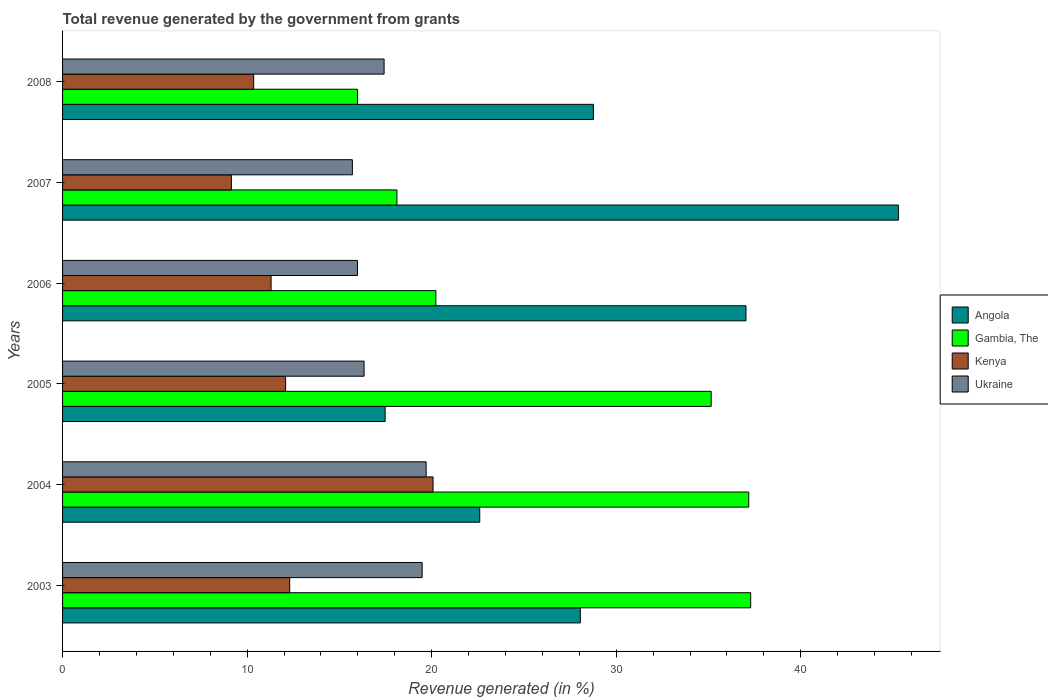How many groups of bars are there?
Keep it short and to the point. 6. How many bars are there on the 6th tick from the bottom?
Provide a short and direct response. 4. What is the total revenue generated in Angola in 2005?
Your answer should be very brief. 17.48. Across all years, what is the maximum total revenue generated in Kenya?
Offer a very short reply. 20.08. Across all years, what is the minimum total revenue generated in Ukraine?
Give a very brief answer. 15.7. In which year was the total revenue generated in Ukraine maximum?
Make the answer very short. 2004. What is the total total revenue generated in Kenya in the graph?
Give a very brief answer. 75.28. What is the difference between the total revenue generated in Kenya in 2005 and that in 2006?
Give a very brief answer. 0.79. What is the difference between the total revenue generated in Kenya in 2005 and the total revenue generated in Ukraine in 2008?
Your answer should be compact. -5.34. What is the average total revenue generated in Ukraine per year?
Offer a terse response. 17.44. In the year 2005, what is the difference between the total revenue generated in Gambia, The and total revenue generated in Kenya?
Your response must be concise. 23.06. In how many years, is the total revenue generated in Kenya greater than 4 %?
Provide a succinct answer. 6. What is the ratio of the total revenue generated in Gambia, The in 2004 to that in 2006?
Your answer should be very brief. 1.84. Is the total revenue generated in Angola in 2004 less than that in 2007?
Make the answer very short. Yes. What is the difference between the highest and the second highest total revenue generated in Ukraine?
Offer a terse response. 0.22. What is the difference between the highest and the lowest total revenue generated in Gambia, The?
Give a very brief answer. 21.3. In how many years, is the total revenue generated in Gambia, The greater than the average total revenue generated in Gambia, The taken over all years?
Your answer should be compact. 3. Is it the case that in every year, the sum of the total revenue generated in Gambia, The and total revenue generated in Angola is greater than the sum of total revenue generated in Ukraine and total revenue generated in Kenya?
Your answer should be compact. Yes. What does the 4th bar from the top in 2008 represents?
Give a very brief answer. Angola. What does the 1st bar from the bottom in 2003 represents?
Offer a terse response. Angola. Are all the bars in the graph horizontal?
Ensure brevity in your answer.  Yes. Are the values on the major ticks of X-axis written in scientific E-notation?
Your response must be concise. No. Does the graph contain any zero values?
Provide a succinct answer. No. How many legend labels are there?
Provide a succinct answer. 4. How are the legend labels stacked?
Your answer should be compact. Vertical. What is the title of the graph?
Your answer should be very brief. Total revenue generated by the government from grants. Does "St. Vincent and the Grenadines" appear as one of the legend labels in the graph?
Ensure brevity in your answer.  No. What is the label or title of the X-axis?
Keep it short and to the point. Revenue generated (in %). What is the label or title of the Y-axis?
Provide a succinct answer. Years. What is the Revenue generated (in %) of Angola in 2003?
Offer a terse response. 28.06. What is the Revenue generated (in %) of Gambia, The in 2003?
Offer a very short reply. 37.29. What is the Revenue generated (in %) in Kenya in 2003?
Your answer should be very brief. 12.31. What is the Revenue generated (in %) of Ukraine in 2003?
Your answer should be compact. 19.49. What is the Revenue generated (in %) in Angola in 2004?
Ensure brevity in your answer.  22.61. What is the Revenue generated (in %) in Gambia, The in 2004?
Your response must be concise. 37.18. What is the Revenue generated (in %) in Kenya in 2004?
Your response must be concise. 20.08. What is the Revenue generated (in %) in Ukraine in 2004?
Offer a very short reply. 19.7. What is the Revenue generated (in %) of Angola in 2005?
Offer a very short reply. 17.48. What is the Revenue generated (in %) of Gambia, The in 2005?
Make the answer very short. 35.15. What is the Revenue generated (in %) in Kenya in 2005?
Offer a very short reply. 12.09. What is the Revenue generated (in %) of Ukraine in 2005?
Make the answer very short. 16.34. What is the Revenue generated (in %) in Angola in 2006?
Keep it short and to the point. 37.03. What is the Revenue generated (in %) of Gambia, The in 2006?
Offer a terse response. 20.23. What is the Revenue generated (in %) in Kenya in 2006?
Ensure brevity in your answer.  11.3. What is the Revenue generated (in %) in Ukraine in 2006?
Offer a very short reply. 15.98. What is the Revenue generated (in %) of Angola in 2007?
Make the answer very short. 45.29. What is the Revenue generated (in %) in Gambia, The in 2007?
Provide a succinct answer. 18.12. What is the Revenue generated (in %) of Kenya in 2007?
Ensure brevity in your answer.  9.15. What is the Revenue generated (in %) in Ukraine in 2007?
Your response must be concise. 15.7. What is the Revenue generated (in %) of Angola in 2008?
Keep it short and to the point. 28.76. What is the Revenue generated (in %) in Gambia, The in 2008?
Ensure brevity in your answer.  15.98. What is the Revenue generated (in %) of Kenya in 2008?
Ensure brevity in your answer.  10.36. What is the Revenue generated (in %) of Ukraine in 2008?
Your answer should be compact. 17.42. Across all years, what is the maximum Revenue generated (in %) in Angola?
Keep it short and to the point. 45.29. Across all years, what is the maximum Revenue generated (in %) of Gambia, The?
Offer a very short reply. 37.29. Across all years, what is the maximum Revenue generated (in %) in Kenya?
Provide a short and direct response. 20.08. Across all years, what is the maximum Revenue generated (in %) in Ukraine?
Your answer should be compact. 19.7. Across all years, what is the minimum Revenue generated (in %) in Angola?
Provide a succinct answer. 17.48. Across all years, what is the minimum Revenue generated (in %) in Gambia, The?
Give a very brief answer. 15.98. Across all years, what is the minimum Revenue generated (in %) in Kenya?
Offer a very short reply. 9.15. Across all years, what is the minimum Revenue generated (in %) in Ukraine?
Provide a short and direct response. 15.7. What is the total Revenue generated (in %) in Angola in the graph?
Provide a succinct answer. 179.23. What is the total Revenue generated (in %) of Gambia, The in the graph?
Keep it short and to the point. 163.95. What is the total Revenue generated (in %) in Kenya in the graph?
Provide a succinct answer. 75.28. What is the total Revenue generated (in %) of Ukraine in the graph?
Give a very brief answer. 104.64. What is the difference between the Revenue generated (in %) of Angola in 2003 and that in 2004?
Provide a short and direct response. 5.45. What is the difference between the Revenue generated (in %) of Gambia, The in 2003 and that in 2004?
Keep it short and to the point. 0.11. What is the difference between the Revenue generated (in %) of Kenya in 2003 and that in 2004?
Your response must be concise. -7.77. What is the difference between the Revenue generated (in %) of Ukraine in 2003 and that in 2004?
Your answer should be very brief. -0.22. What is the difference between the Revenue generated (in %) in Angola in 2003 and that in 2005?
Offer a terse response. 10.58. What is the difference between the Revenue generated (in %) in Gambia, The in 2003 and that in 2005?
Provide a succinct answer. 2.14. What is the difference between the Revenue generated (in %) of Kenya in 2003 and that in 2005?
Offer a terse response. 0.22. What is the difference between the Revenue generated (in %) in Ukraine in 2003 and that in 2005?
Offer a terse response. 3.15. What is the difference between the Revenue generated (in %) in Angola in 2003 and that in 2006?
Provide a short and direct response. -8.98. What is the difference between the Revenue generated (in %) of Gambia, The in 2003 and that in 2006?
Your answer should be compact. 17.06. What is the difference between the Revenue generated (in %) of Kenya in 2003 and that in 2006?
Provide a short and direct response. 1.01. What is the difference between the Revenue generated (in %) in Ukraine in 2003 and that in 2006?
Keep it short and to the point. 3.5. What is the difference between the Revenue generated (in %) in Angola in 2003 and that in 2007?
Offer a terse response. -17.24. What is the difference between the Revenue generated (in %) in Gambia, The in 2003 and that in 2007?
Give a very brief answer. 19.17. What is the difference between the Revenue generated (in %) of Kenya in 2003 and that in 2007?
Offer a terse response. 3.16. What is the difference between the Revenue generated (in %) of Ukraine in 2003 and that in 2007?
Offer a terse response. 3.78. What is the difference between the Revenue generated (in %) of Angola in 2003 and that in 2008?
Make the answer very short. -0.71. What is the difference between the Revenue generated (in %) in Gambia, The in 2003 and that in 2008?
Keep it short and to the point. 21.3. What is the difference between the Revenue generated (in %) of Kenya in 2003 and that in 2008?
Give a very brief answer. 1.95. What is the difference between the Revenue generated (in %) of Ukraine in 2003 and that in 2008?
Ensure brevity in your answer.  2.06. What is the difference between the Revenue generated (in %) of Angola in 2004 and that in 2005?
Ensure brevity in your answer.  5.13. What is the difference between the Revenue generated (in %) in Gambia, The in 2004 and that in 2005?
Your response must be concise. 2.04. What is the difference between the Revenue generated (in %) in Kenya in 2004 and that in 2005?
Make the answer very short. 7.99. What is the difference between the Revenue generated (in %) of Ukraine in 2004 and that in 2005?
Your answer should be very brief. 3.36. What is the difference between the Revenue generated (in %) in Angola in 2004 and that in 2006?
Offer a very short reply. -14.43. What is the difference between the Revenue generated (in %) in Gambia, The in 2004 and that in 2006?
Keep it short and to the point. 16.95. What is the difference between the Revenue generated (in %) of Kenya in 2004 and that in 2006?
Your answer should be compact. 8.78. What is the difference between the Revenue generated (in %) in Ukraine in 2004 and that in 2006?
Provide a short and direct response. 3.72. What is the difference between the Revenue generated (in %) in Angola in 2004 and that in 2007?
Ensure brevity in your answer.  -22.69. What is the difference between the Revenue generated (in %) of Gambia, The in 2004 and that in 2007?
Ensure brevity in your answer.  19.06. What is the difference between the Revenue generated (in %) in Kenya in 2004 and that in 2007?
Your answer should be compact. 10.93. What is the difference between the Revenue generated (in %) in Ukraine in 2004 and that in 2007?
Your answer should be compact. 4. What is the difference between the Revenue generated (in %) of Angola in 2004 and that in 2008?
Give a very brief answer. -6.16. What is the difference between the Revenue generated (in %) in Gambia, The in 2004 and that in 2008?
Ensure brevity in your answer.  21.2. What is the difference between the Revenue generated (in %) of Kenya in 2004 and that in 2008?
Provide a succinct answer. 9.72. What is the difference between the Revenue generated (in %) of Ukraine in 2004 and that in 2008?
Offer a very short reply. 2.28. What is the difference between the Revenue generated (in %) in Angola in 2005 and that in 2006?
Your response must be concise. -19.56. What is the difference between the Revenue generated (in %) of Gambia, The in 2005 and that in 2006?
Your response must be concise. 14.92. What is the difference between the Revenue generated (in %) of Kenya in 2005 and that in 2006?
Your answer should be compact. 0.79. What is the difference between the Revenue generated (in %) in Ukraine in 2005 and that in 2006?
Offer a terse response. 0.36. What is the difference between the Revenue generated (in %) of Angola in 2005 and that in 2007?
Make the answer very short. -27.81. What is the difference between the Revenue generated (in %) of Gambia, The in 2005 and that in 2007?
Offer a terse response. 17.03. What is the difference between the Revenue generated (in %) of Kenya in 2005 and that in 2007?
Your response must be concise. 2.94. What is the difference between the Revenue generated (in %) of Ukraine in 2005 and that in 2007?
Make the answer very short. 0.63. What is the difference between the Revenue generated (in %) in Angola in 2005 and that in 2008?
Your answer should be compact. -11.29. What is the difference between the Revenue generated (in %) in Gambia, The in 2005 and that in 2008?
Give a very brief answer. 19.16. What is the difference between the Revenue generated (in %) in Kenya in 2005 and that in 2008?
Ensure brevity in your answer.  1.73. What is the difference between the Revenue generated (in %) in Ukraine in 2005 and that in 2008?
Provide a succinct answer. -1.08. What is the difference between the Revenue generated (in %) in Angola in 2006 and that in 2007?
Your answer should be compact. -8.26. What is the difference between the Revenue generated (in %) of Gambia, The in 2006 and that in 2007?
Your answer should be very brief. 2.11. What is the difference between the Revenue generated (in %) in Kenya in 2006 and that in 2007?
Provide a short and direct response. 2.15. What is the difference between the Revenue generated (in %) in Ukraine in 2006 and that in 2007?
Offer a very short reply. 0.28. What is the difference between the Revenue generated (in %) of Angola in 2006 and that in 2008?
Your answer should be compact. 8.27. What is the difference between the Revenue generated (in %) in Gambia, The in 2006 and that in 2008?
Your answer should be compact. 4.25. What is the difference between the Revenue generated (in %) in Kenya in 2006 and that in 2008?
Keep it short and to the point. 0.94. What is the difference between the Revenue generated (in %) of Ukraine in 2006 and that in 2008?
Provide a succinct answer. -1.44. What is the difference between the Revenue generated (in %) in Angola in 2007 and that in 2008?
Offer a terse response. 16.53. What is the difference between the Revenue generated (in %) in Gambia, The in 2007 and that in 2008?
Keep it short and to the point. 2.13. What is the difference between the Revenue generated (in %) in Kenya in 2007 and that in 2008?
Give a very brief answer. -1.21. What is the difference between the Revenue generated (in %) in Ukraine in 2007 and that in 2008?
Ensure brevity in your answer.  -1.72. What is the difference between the Revenue generated (in %) in Angola in 2003 and the Revenue generated (in %) in Gambia, The in 2004?
Offer a very short reply. -9.13. What is the difference between the Revenue generated (in %) of Angola in 2003 and the Revenue generated (in %) of Kenya in 2004?
Make the answer very short. 7.98. What is the difference between the Revenue generated (in %) of Angola in 2003 and the Revenue generated (in %) of Ukraine in 2004?
Your answer should be very brief. 8.36. What is the difference between the Revenue generated (in %) of Gambia, The in 2003 and the Revenue generated (in %) of Kenya in 2004?
Your answer should be very brief. 17.21. What is the difference between the Revenue generated (in %) of Gambia, The in 2003 and the Revenue generated (in %) of Ukraine in 2004?
Ensure brevity in your answer.  17.59. What is the difference between the Revenue generated (in %) of Kenya in 2003 and the Revenue generated (in %) of Ukraine in 2004?
Provide a short and direct response. -7.39. What is the difference between the Revenue generated (in %) in Angola in 2003 and the Revenue generated (in %) in Gambia, The in 2005?
Your answer should be very brief. -7.09. What is the difference between the Revenue generated (in %) in Angola in 2003 and the Revenue generated (in %) in Kenya in 2005?
Give a very brief answer. 15.97. What is the difference between the Revenue generated (in %) in Angola in 2003 and the Revenue generated (in %) in Ukraine in 2005?
Your answer should be compact. 11.72. What is the difference between the Revenue generated (in %) in Gambia, The in 2003 and the Revenue generated (in %) in Kenya in 2005?
Provide a short and direct response. 25.2. What is the difference between the Revenue generated (in %) in Gambia, The in 2003 and the Revenue generated (in %) in Ukraine in 2005?
Ensure brevity in your answer.  20.95. What is the difference between the Revenue generated (in %) of Kenya in 2003 and the Revenue generated (in %) of Ukraine in 2005?
Provide a short and direct response. -4.03. What is the difference between the Revenue generated (in %) in Angola in 2003 and the Revenue generated (in %) in Gambia, The in 2006?
Make the answer very short. 7.83. What is the difference between the Revenue generated (in %) in Angola in 2003 and the Revenue generated (in %) in Kenya in 2006?
Offer a terse response. 16.76. What is the difference between the Revenue generated (in %) of Angola in 2003 and the Revenue generated (in %) of Ukraine in 2006?
Provide a succinct answer. 12.08. What is the difference between the Revenue generated (in %) of Gambia, The in 2003 and the Revenue generated (in %) of Kenya in 2006?
Offer a very short reply. 25.99. What is the difference between the Revenue generated (in %) of Gambia, The in 2003 and the Revenue generated (in %) of Ukraine in 2006?
Your answer should be very brief. 21.31. What is the difference between the Revenue generated (in %) of Kenya in 2003 and the Revenue generated (in %) of Ukraine in 2006?
Your response must be concise. -3.67. What is the difference between the Revenue generated (in %) in Angola in 2003 and the Revenue generated (in %) in Gambia, The in 2007?
Offer a very short reply. 9.94. What is the difference between the Revenue generated (in %) in Angola in 2003 and the Revenue generated (in %) in Kenya in 2007?
Offer a very short reply. 18.91. What is the difference between the Revenue generated (in %) of Angola in 2003 and the Revenue generated (in %) of Ukraine in 2007?
Offer a very short reply. 12.35. What is the difference between the Revenue generated (in %) of Gambia, The in 2003 and the Revenue generated (in %) of Kenya in 2007?
Ensure brevity in your answer.  28.14. What is the difference between the Revenue generated (in %) of Gambia, The in 2003 and the Revenue generated (in %) of Ukraine in 2007?
Ensure brevity in your answer.  21.58. What is the difference between the Revenue generated (in %) in Kenya in 2003 and the Revenue generated (in %) in Ukraine in 2007?
Ensure brevity in your answer.  -3.4. What is the difference between the Revenue generated (in %) of Angola in 2003 and the Revenue generated (in %) of Gambia, The in 2008?
Keep it short and to the point. 12.07. What is the difference between the Revenue generated (in %) of Angola in 2003 and the Revenue generated (in %) of Kenya in 2008?
Ensure brevity in your answer.  17.7. What is the difference between the Revenue generated (in %) of Angola in 2003 and the Revenue generated (in %) of Ukraine in 2008?
Offer a terse response. 10.63. What is the difference between the Revenue generated (in %) of Gambia, The in 2003 and the Revenue generated (in %) of Kenya in 2008?
Ensure brevity in your answer.  26.93. What is the difference between the Revenue generated (in %) in Gambia, The in 2003 and the Revenue generated (in %) in Ukraine in 2008?
Provide a succinct answer. 19.86. What is the difference between the Revenue generated (in %) of Kenya in 2003 and the Revenue generated (in %) of Ukraine in 2008?
Ensure brevity in your answer.  -5.11. What is the difference between the Revenue generated (in %) of Angola in 2004 and the Revenue generated (in %) of Gambia, The in 2005?
Give a very brief answer. -12.54. What is the difference between the Revenue generated (in %) of Angola in 2004 and the Revenue generated (in %) of Kenya in 2005?
Offer a very short reply. 10.52. What is the difference between the Revenue generated (in %) of Angola in 2004 and the Revenue generated (in %) of Ukraine in 2005?
Provide a short and direct response. 6.27. What is the difference between the Revenue generated (in %) in Gambia, The in 2004 and the Revenue generated (in %) in Kenya in 2005?
Keep it short and to the point. 25.1. What is the difference between the Revenue generated (in %) in Gambia, The in 2004 and the Revenue generated (in %) in Ukraine in 2005?
Give a very brief answer. 20.84. What is the difference between the Revenue generated (in %) of Kenya in 2004 and the Revenue generated (in %) of Ukraine in 2005?
Your answer should be very brief. 3.74. What is the difference between the Revenue generated (in %) in Angola in 2004 and the Revenue generated (in %) in Gambia, The in 2006?
Your answer should be compact. 2.38. What is the difference between the Revenue generated (in %) of Angola in 2004 and the Revenue generated (in %) of Kenya in 2006?
Your answer should be very brief. 11.31. What is the difference between the Revenue generated (in %) of Angola in 2004 and the Revenue generated (in %) of Ukraine in 2006?
Ensure brevity in your answer.  6.62. What is the difference between the Revenue generated (in %) in Gambia, The in 2004 and the Revenue generated (in %) in Kenya in 2006?
Your answer should be very brief. 25.88. What is the difference between the Revenue generated (in %) in Gambia, The in 2004 and the Revenue generated (in %) in Ukraine in 2006?
Offer a very short reply. 21.2. What is the difference between the Revenue generated (in %) of Kenya in 2004 and the Revenue generated (in %) of Ukraine in 2006?
Provide a short and direct response. 4.1. What is the difference between the Revenue generated (in %) of Angola in 2004 and the Revenue generated (in %) of Gambia, The in 2007?
Your answer should be very brief. 4.49. What is the difference between the Revenue generated (in %) of Angola in 2004 and the Revenue generated (in %) of Kenya in 2007?
Your response must be concise. 13.46. What is the difference between the Revenue generated (in %) of Angola in 2004 and the Revenue generated (in %) of Ukraine in 2007?
Provide a succinct answer. 6.9. What is the difference between the Revenue generated (in %) in Gambia, The in 2004 and the Revenue generated (in %) in Kenya in 2007?
Offer a terse response. 28.04. What is the difference between the Revenue generated (in %) in Gambia, The in 2004 and the Revenue generated (in %) in Ukraine in 2007?
Your response must be concise. 21.48. What is the difference between the Revenue generated (in %) of Kenya in 2004 and the Revenue generated (in %) of Ukraine in 2007?
Your answer should be very brief. 4.37. What is the difference between the Revenue generated (in %) in Angola in 2004 and the Revenue generated (in %) in Gambia, The in 2008?
Ensure brevity in your answer.  6.62. What is the difference between the Revenue generated (in %) in Angola in 2004 and the Revenue generated (in %) in Kenya in 2008?
Provide a short and direct response. 12.25. What is the difference between the Revenue generated (in %) of Angola in 2004 and the Revenue generated (in %) of Ukraine in 2008?
Offer a terse response. 5.18. What is the difference between the Revenue generated (in %) of Gambia, The in 2004 and the Revenue generated (in %) of Kenya in 2008?
Your response must be concise. 26.83. What is the difference between the Revenue generated (in %) in Gambia, The in 2004 and the Revenue generated (in %) in Ukraine in 2008?
Provide a short and direct response. 19.76. What is the difference between the Revenue generated (in %) of Kenya in 2004 and the Revenue generated (in %) of Ukraine in 2008?
Make the answer very short. 2.65. What is the difference between the Revenue generated (in %) in Angola in 2005 and the Revenue generated (in %) in Gambia, The in 2006?
Offer a terse response. -2.75. What is the difference between the Revenue generated (in %) of Angola in 2005 and the Revenue generated (in %) of Kenya in 2006?
Your response must be concise. 6.18. What is the difference between the Revenue generated (in %) of Angola in 2005 and the Revenue generated (in %) of Ukraine in 2006?
Offer a very short reply. 1.5. What is the difference between the Revenue generated (in %) of Gambia, The in 2005 and the Revenue generated (in %) of Kenya in 2006?
Keep it short and to the point. 23.85. What is the difference between the Revenue generated (in %) in Gambia, The in 2005 and the Revenue generated (in %) in Ukraine in 2006?
Offer a very short reply. 19.17. What is the difference between the Revenue generated (in %) of Kenya in 2005 and the Revenue generated (in %) of Ukraine in 2006?
Your answer should be very brief. -3.89. What is the difference between the Revenue generated (in %) of Angola in 2005 and the Revenue generated (in %) of Gambia, The in 2007?
Provide a succinct answer. -0.64. What is the difference between the Revenue generated (in %) of Angola in 2005 and the Revenue generated (in %) of Kenya in 2007?
Make the answer very short. 8.33. What is the difference between the Revenue generated (in %) of Angola in 2005 and the Revenue generated (in %) of Ukraine in 2007?
Your answer should be very brief. 1.77. What is the difference between the Revenue generated (in %) in Gambia, The in 2005 and the Revenue generated (in %) in Kenya in 2007?
Keep it short and to the point. 26. What is the difference between the Revenue generated (in %) of Gambia, The in 2005 and the Revenue generated (in %) of Ukraine in 2007?
Give a very brief answer. 19.44. What is the difference between the Revenue generated (in %) in Kenya in 2005 and the Revenue generated (in %) in Ukraine in 2007?
Ensure brevity in your answer.  -3.62. What is the difference between the Revenue generated (in %) in Angola in 2005 and the Revenue generated (in %) in Gambia, The in 2008?
Keep it short and to the point. 1.49. What is the difference between the Revenue generated (in %) of Angola in 2005 and the Revenue generated (in %) of Kenya in 2008?
Make the answer very short. 7.12. What is the difference between the Revenue generated (in %) of Angola in 2005 and the Revenue generated (in %) of Ukraine in 2008?
Keep it short and to the point. 0.06. What is the difference between the Revenue generated (in %) of Gambia, The in 2005 and the Revenue generated (in %) of Kenya in 2008?
Keep it short and to the point. 24.79. What is the difference between the Revenue generated (in %) in Gambia, The in 2005 and the Revenue generated (in %) in Ukraine in 2008?
Offer a very short reply. 17.72. What is the difference between the Revenue generated (in %) of Kenya in 2005 and the Revenue generated (in %) of Ukraine in 2008?
Your answer should be very brief. -5.34. What is the difference between the Revenue generated (in %) of Angola in 2006 and the Revenue generated (in %) of Gambia, The in 2007?
Offer a terse response. 18.92. What is the difference between the Revenue generated (in %) of Angola in 2006 and the Revenue generated (in %) of Kenya in 2007?
Offer a very short reply. 27.89. What is the difference between the Revenue generated (in %) of Angola in 2006 and the Revenue generated (in %) of Ukraine in 2007?
Your response must be concise. 21.33. What is the difference between the Revenue generated (in %) in Gambia, The in 2006 and the Revenue generated (in %) in Kenya in 2007?
Your answer should be very brief. 11.08. What is the difference between the Revenue generated (in %) of Gambia, The in 2006 and the Revenue generated (in %) of Ukraine in 2007?
Offer a very short reply. 4.53. What is the difference between the Revenue generated (in %) in Kenya in 2006 and the Revenue generated (in %) in Ukraine in 2007?
Offer a terse response. -4.41. What is the difference between the Revenue generated (in %) in Angola in 2006 and the Revenue generated (in %) in Gambia, The in 2008?
Provide a short and direct response. 21.05. What is the difference between the Revenue generated (in %) of Angola in 2006 and the Revenue generated (in %) of Kenya in 2008?
Offer a very short reply. 26.68. What is the difference between the Revenue generated (in %) in Angola in 2006 and the Revenue generated (in %) in Ukraine in 2008?
Make the answer very short. 19.61. What is the difference between the Revenue generated (in %) of Gambia, The in 2006 and the Revenue generated (in %) of Kenya in 2008?
Keep it short and to the point. 9.87. What is the difference between the Revenue generated (in %) of Gambia, The in 2006 and the Revenue generated (in %) of Ukraine in 2008?
Your answer should be compact. 2.81. What is the difference between the Revenue generated (in %) of Kenya in 2006 and the Revenue generated (in %) of Ukraine in 2008?
Give a very brief answer. -6.12. What is the difference between the Revenue generated (in %) in Angola in 2007 and the Revenue generated (in %) in Gambia, The in 2008?
Offer a terse response. 29.31. What is the difference between the Revenue generated (in %) in Angola in 2007 and the Revenue generated (in %) in Kenya in 2008?
Keep it short and to the point. 34.94. What is the difference between the Revenue generated (in %) in Angola in 2007 and the Revenue generated (in %) in Ukraine in 2008?
Offer a very short reply. 27.87. What is the difference between the Revenue generated (in %) in Gambia, The in 2007 and the Revenue generated (in %) in Kenya in 2008?
Keep it short and to the point. 7.76. What is the difference between the Revenue generated (in %) in Gambia, The in 2007 and the Revenue generated (in %) in Ukraine in 2008?
Provide a succinct answer. 0.7. What is the difference between the Revenue generated (in %) of Kenya in 2007 and the Revenue generated (in %) of Ukraine in 2008?
Give a very brief answer. -8.28. What is the average Revenue generated (in %) in Angola per year?
Offer a terse response. 29.87. What is the average Revenue generated (in %) in Gambia, The per year?
Ensure brevity in your answer.  27.32. What is the average Revenue generated (in %) of Kenya per year?
Provide a succinct answer. 12.55. What is the average Revenue generated (in %) of Ukraine per year?
Your response must be concise. 17.44. In the year 2003, what is the difference between the Revenue generated (in %) of Angola and Revenue generated (in %) of Gambia, The?
Your response must be concise. -9.23. In the year 2003, what is the difference between the Revenue generated (in %) of Angola and Revenue generated (in %) of Kenya?
Provide a short and direct response. 15.75. In the year 2003, what is the difference between the Revenue generated (in %) of Angola and Revenue generated (in %) of Ukraine?
Your answer should be very brief. 8.57. In the year 2003, what is the difference between the Revenue generated (in %) of Gambia, The and Revenue generated (in %) of Kenya?
Your answer should be compact. 24.98. In the year 2003, what is the difference between the Revenue generated (in %) of Gambia, The and Revenue generated (in %) of Ukraine?
Offer a very short reply. 17.8. In the year 2003, what is the difference between the Revenue generated (in %) of Kenya and Revenue generated (in %) of Ukraine?
Your answer should be very brief. -7.18. In the year 2004, what is the difference between the Revenue generated (in %) in Angola and Revenue generated (in %) in Gambia, The?
Keep it short and to the point. -14.58. In the year 2004, what is the difference between the Revenue generated (in %) in Angola and Revenue generated (in %) in Kenya?
Give a very brief answer. 2.53. In the year 2004, what is the difference between the Revenue generated (in %) of Angola and Revenue generated (in %) of Ukraine?
Your answer should be compact. 2.9. In the year 2004, what is the difference between the Revenue generated (in %) of Gambia, The and Revenue generated (in %) of Kenya?
Offer a very short reply. 17.11. In the year 2004, what is the difference between the Revenue generated (in %) of Gambia, The and Revenue generated (in %) of Ukraine?
Your answer should be compact. 17.48. In the year 2004, what is the difference between the Revenue generated (in %) in Kenya and Revenue generated (in %) in Ukraine?
Offer a terse response. 0.38. In the year 2005, what is the difference between the Revenue generated (in %) in Angola and Revenue generated (in %) in Gambia, The?
Your response must be concise. -17.67. In the year 2005, what is the difference between the Revenue generated (in %) of Angola and Revenue generated (in %) of Kenya?
Offer a very short reply. 5.39. In the year 2005, what is the difference between the Revenue generated (in %) of Angola and Revenue generated (in %) of Ukraine?
Provide a succinct answer. 1.14. In the year 2005, what is the difference between the Revenue generated (in %) in Gambia, The and Revenue generated (in %) in Kenya?
Offer a terse response. 23.06. In the year 2005, what is the difference between the Revenue generated (in %) of Gambia, The and Revenue generated (in %) of Ukraine?
Your answer should be very brief. 18.81. In the year 2005, what is the difference between the Revenue generated (in %) of Kenya and Revenue generated (in %) of Ukraine?
Provide a succinct answer. -4.25. In the year 2006, what is the difference between the Revenue generated (in %) of Angola and Revenue generated (in %) of Gambia, The?
Offer a very short reply. 16.8. In the year 2006, what is the difference between the Revenue generated (in %) in Angola and Revenue generated (in %) in Kenya?
Offer a terse response. 25.73. In the year 2006, what is the difference between the Revenue generated (in %) of Angola and Revenue generated (in %) of Ukraine?
Give a very brief answer. 21.05. In the year 2006, what is the difference between the Revenue generated (in %) in Gambia, The and Revenue generated (in %) in Kenya?
Give a very brief answer. 8.93. In the year 2006, what is the difference between the Revenue generated (in %) of Gambia, The and Revenue generated (in %) of Ukraine?
Your answer should be very brief. 4.25. In the year 2006, what is the difference between the Revenue generated (in %) in Kenya and Revenue generated (in %) in Ukraine?
Keep it short and to the point. -4.68. In the year 2007, what is the difference between the Revenue generated (in %) in Angola and Revenue generated (in %) in Gambia, The?
Your answer should be compact. 27.17. In the year 2007, what is the difference between the Revenue generated (in %) in Angola and Revenue generated (in %) in Kenya?
Your answer should be compact. 36.15. In the year 2007, what is the difference between the Revenue generated (in %) in Angola and Revenue generated (in %) in Ukraine?
Offer a terse response. 29.59. In the year 2007, what is the difference between the Revenue generated (in %) of Gambia, The and Revenue generated (in %) of Kenya?
Offer a very short reply. 8.97. In the year 2007, what is the difference between the Revenue generated (in %) in Gambia, The and Revenue generated (in %) in Ukraine?
Provide a succinct answer. 2.41. In the year 2007, what is the difference between the Revenue generated (in %) in Kenya and Revenue generated (in %) in Ukraine?
Your answer should be very brief. -6.56. In the year 2008, what is the difference between the Revenue generated (in %) of Angola and Revenue generated (in %) of Gambia, The?
Provide a succinct answer. 12.78. In the year 2008, what is the difference between the Revenue generated (in %) of Angola and Revenue generated (in %) of Kenya?
Your response must be concise. 18.41. In the year 2008, what is the difference between the Revenue generated (in %) in Angola and Revenue generated (in %) in Ukraine?
Offer a very short reply. 11.34. In the year 2008, what is the difference between the Revenue generated (in %) of Gambia, The and Revenue generated (in %) of Kenya?
Provide a succinct answer. 5.63. In the year 2008, what is the difference between the Revenue generated (in %) of Gambia, The and Revenue generated (in %) of Ukraine?
Your answer should be compact. -1.44. In the year 2008, what is the difference between the Revenue generated (in %) in Kenya and Revenue generated (in %) in Ukraine?
Offer a very short reply. -7.07. What is the ratio of the Revenue generated (in %) in Angola in 2003 to that in 2004?
Your answer should be compact. 1.24. What is the ratio of the Revenue generated (in %) in Gambia, The in 2003 to that in 2004?
Provide a short and direct response. 1. What is the ratio of the Revenue generated (in %) in Kenya in 2003 to that in 2004?
Offer a very short reply. 0.61. What is the ratio of the Revenue generated (in %) in Ukraine in 2003 to that in 2004?
Provide a short and direct response. 0.99. What is the ratio of the Revenue generated (in %) of Angola in 2003 to that in 2005?
Your response must be concise. 1.61. What is the ratio of the Revenue generated (in %) of Gambia, The in 2003 to that in 2005?
Offer a terse response. 1.06. What is the ratio of the Revenue generated (in %) in Kenya in 2003 to that in 2005?
Provide a short and direct response. 1.02. What is the ratio of the Revenue generated (in %) in Ukraine in 2003 to that in 2005?
Offer a terse response. 1.19. What is the ratio of the Revenue generated (in %) of Angola in 2003 to that in 2006?
Keep it short and to the point. 0.76. What is the ratio of the Revenue generated (in %) of Gambia, The in 2003 to that in 2006?
Give a very brief answer. 1.84. What is the ratio of the Revenue generated (in %) of Kenya in 2003 to that in 2006?
Make the answer very short. 1.09. What is the ratio of the Revenue generated (in %) of Ukraine in 2003 to that in 2006?
Your answer should be very brief. 1.22. What is the ratio of the Revenue generated (in %) in Angola in 2003 to that in 2007?
Offer a terse response. 0.62. What is the ratio of the Revenue generated (in %) in Gambia, The in 2003 to that in 2007?
Your answer should be very brief. 2.06. What is the ratio of the Revenue generated (in %) of Kenya in 2003 to that in 2007?
Your response must be concise. 1.35. What is the ratio of the Revenue generated (in %) in Ukraine in 2003 to that in 2007?
Offer a very short reply. 1.24. What is the ratio of the Revenue generated (in %) in Angola in 2003 to that in 2008?
Offer a terse response. 0.98. What is the ratio of the Revenue generated (in %) in Gambia, The in 2003 to that in 2008?
Give a very brief answer. 2.33. What is the ratio of the Revenue generated (in %) in Kenya in 2003 to that in 2008?
Provide a succinct answer. 1.19. What is the ratio of the Revenue generated (in %) in Ukraine in 2003 to that in 2008?
Keep it short and to the point. 1.12. What is the ratio of the Revenue generated (in %) in Angola in 2004 to that in 2005?
Provide a short and direct response. 1.29. What is the ratio of the Revenue generated (in %) of Gambia, The in 2004 to that in 2005?
Ensure brevity in your answer.  1.06. What is the ratio of the Revenue generated (in %) of Kenya in 2004 to that in 2005?
Provide a short and direct response. 1.66. What is the ratio of the Revenue generated (in %) in Ukraine in 2004 to that in 2005?
Your response must be concise. 1.21. What is the ratio of the Revenue generated (in %) of Angola in 2004 to that in 2006?
Your answer should be compact. 0.61. What is the ratio of the Revenue generated (in %) of Gambia, The in 2004 to that in 2006?
Provide a succinct answer. 1.84. What is the ratio of the Revenue generated (in %) in Kenya in 2004 to that in 2006?
Give a very brief answer. 1.78. What is the ratio of the Revenue generated (in %) of Ukraine in 2004 to that in 2006?
Provide a short and direct response. 1.23. What is the ratio of the Revenue generated (in %) in Angola in 2004 to that in 2007?
Ensure brevity in your answer.  0.5. What is the ratio of the Revenue generated (in %) in Gambia, The in 2004 to that in 2007?
Keep it short and to the point. 2.05. What is the ratio of the Revenue generated (in %) in Kenya in 2004 to that in 2007?
Your answer should be compact. 2.19. What is the ratio of the Revenue generated (in %) in Ukraine in 2004 to that in 2007?
Make the answer very short. 1.25. What is the ratio of the Revenue generated (in %) in Angola in 2004 to that in 2008?
Give a very brief answer. 0.79. What is the ratio of the Revenue generated (in %) of Gambia, The in 2004 to that in 2008?
Your answer should be compact. 2.33. What is the ratio of the Revenue generated (in %) in Kenya in 2004 to that in 2008?
Offer a very short reply. 1.94. What is the ratio of the Revenue generated (in %) in Ukraine in 2004 to that in 2008?
Provide a succinct answer. 1.13. What is the ratio of the Revenue generated (in %) of Angola in 2005 to that in 2006?
Ensure brevity in your answer.  0.47. What is the ratio of the Revenue generated (in %) in Gambia, The in 2005 to that in 2006?
Make the answer very short. 1.74. What is the ratio of the Revenue generated (in %) in Kenya in 2005 to that in 2006?
Your answer should be compact. 1.07. What is the ratio of the Revenue generated (in %) in Ukraine in 2005 to that in 2006?
Ensure brevity in your answer.  1.02. What is the ratio of the Revenue generated (in %) of Angola in 2005 to that in 2007?
Give a very brief answer. 0.39. What is the ratio of the Revenue generated (in %) in Gambia, The in 2005 to that in 2007?
Offer a terse response. 1.94. What is the ratio of the Revenue generated (in %) of Kenya in 2005 to that in 2007?
Your answer should be very brief. 1.32. What is the ratio of the Revenue generated (in %) in Ukraine in 2005 to that in 2007?
Offer a terse response. 1.04. What is the ratio of the Revenue generated (in %) of Angola in 2005 to that in 2008?
Provide a succinct answer. 0.61. What is the ratio of the Revenue generated (in %) of Gambia, The in 2005 to that in 2008?
Give a very brief answer. 2.2. What is the ratio of the Revenue generated (in %) in Kenya in 2005 to that in 2008?
Your response must be concise. 1.17. What is the ratio of the Revenue generated (in %) in Ukraine in 2005 to that in 2008?
Give a very brief answer. 0.94. What is the ratio of the Revenue generated (in %) in Angola in 2006 to that in 2007?
Keep it short and to the point. 0.82. What is the ratio of the Revenue generated (in %) of Gambia, The in 2006 to that in 2007?
Provide a succinct answer. 1.12. What is the ratio of the Revenue generated (in %) of Kenya in 2006 to that in 2007?
Provide a succinct answer. 1.24. What is the ratio of the Revenue generated (in %) in Ukraine in 2006 to that in 2007?
Your answer should be very brief. 1.02. What is the ratio of the Revenue generated (in %) of Angola in 2006 to that in 2008?
Provide a short and direct response. 1.29. What is the ratio of the Revenue generated (in %) in Gambia, The in 2006 to that in 2008?
Offer a very short reply. 1.27. What is the ratio of the Revenue generated (in %) in Kenya in 2006 to that in 2008?
Offer a terse response. 1.09. What is the ratio of the Revenue generated (in %) of Ukraine in 2006 to that in 2008?
Provide a succinct answer. 0.92. What is the ratio of the Revenue generated (in %) in Angola in 2007 to that in 2008?
Provide a short and direct response. 1.57. What is the ratio of the Revenue generated (in %) of Gambia, The in 2007 to that in 2008?
Offer a terse response. 1.13. What is the ratio of the Revenue generated (in %) in Kenya in 2007 to that in 2008?
Ensure brevity in your answer.  0.88. What is the ratio of the Revenue generated (in %) in Ukraine in 2007 to that in 2008?
Ensure brevity in your answer.  0.9. What is the difference between the highest and the second highest Revenue generated (in %) of Angola?
Your answer should be very brief. 8.26. What is the difference between the highest and the second highest Revenue generated (in %) in Gambia, The?
Make the answer very short. 0.11. What is the difference between the highest and the second highest Revenue generated (in %) in Kenya?
Provide a short and direct response. 7.77. What is the difference between the highest and the second highest Revenue generated (in %) in Ukraine?
Provide a short and direct response. 0.22. What is the difference between the highest and the lowest Revenue generated (in %) of Angola?
Your answer should be compact. 27.81. What is the difference between the highest and the lowest Revenue generated (in %) of Gambia, The?
Provide a short and direct response. 21.3. What is the difference between the highest and the lowest Revenue generated (in %) in Kenya?
Give a very brief answer. 10.93. What is the difference between the highest and the lowest Revenue generated (in %) in Ukraine?
Make the answer very short. 4. 